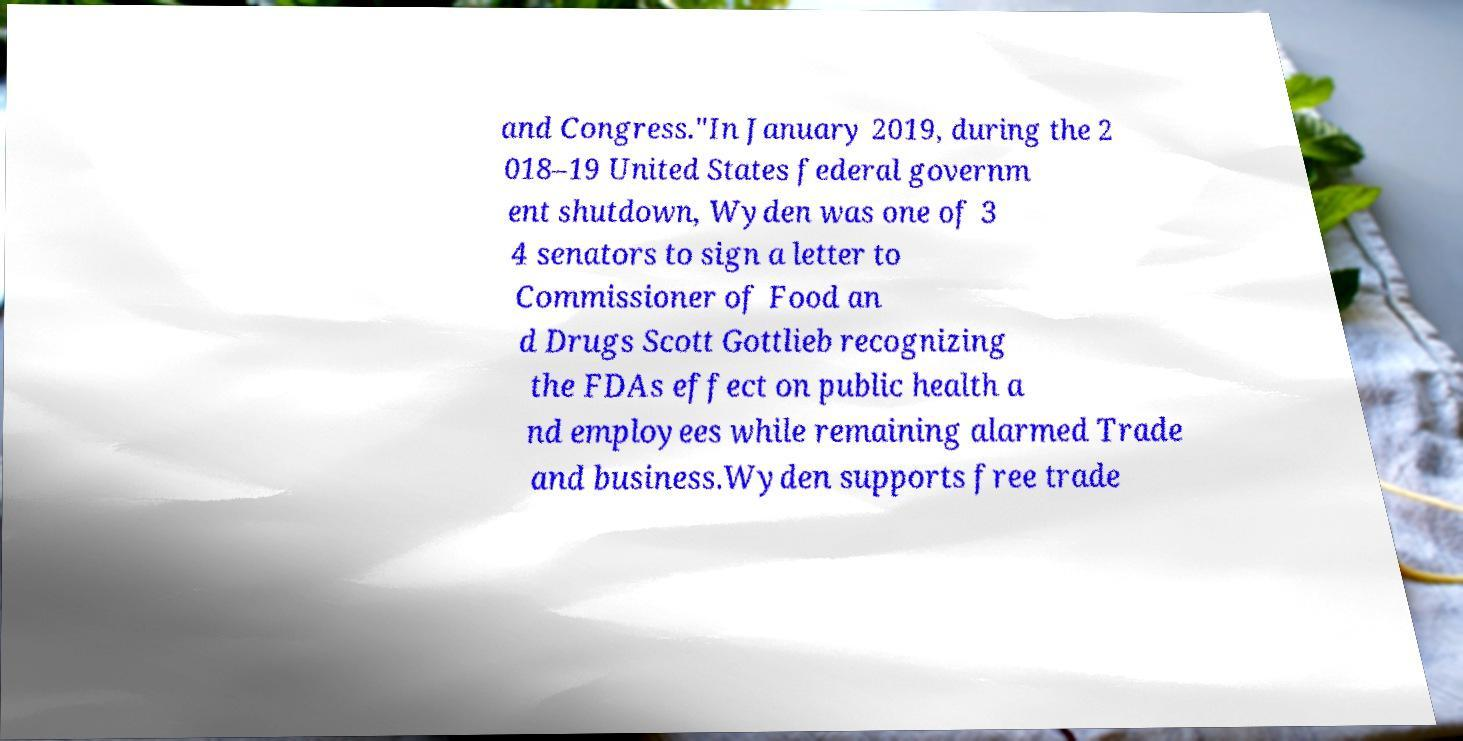Could you extract and type out the text from this image? and Congress."In January 2019, during the 2 018–19 United States federal governm ent shutdown, Wyden was one of 3 4 senators to sign a letter to Commissioner of Food an d Drugs Scott Gottlieb recognizing the FDAs effect on public health a nd employees while remaining alarmed Trade and business.Wyden supports free trade 